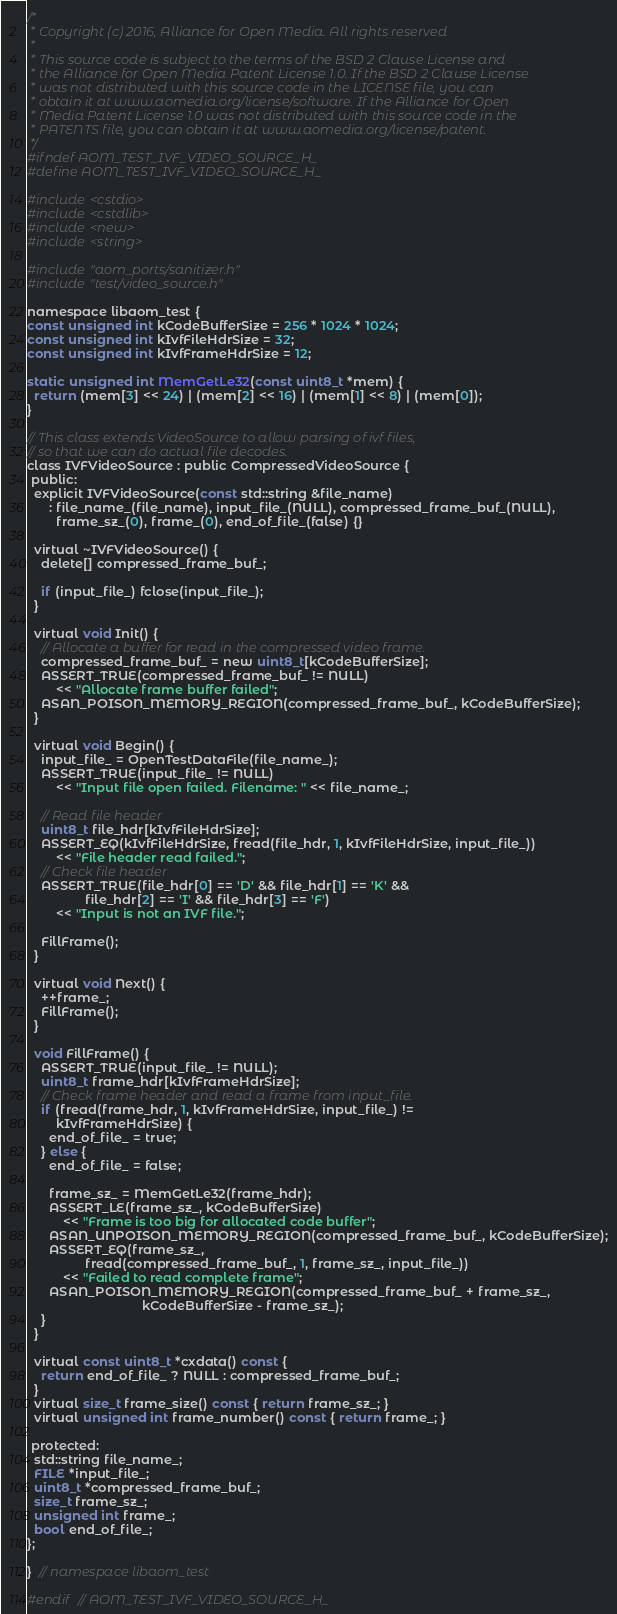Convert code to text. <code><loc_0><loc_0><loc_500><loc_500><_C_>/*
 * Copyright (c) 2016, Alliance for Open Media. All rights reserved
 *
 * This source code is subject to the terms of the BSD 2 Clause License and
 * the Alliance for Open Media Patent License 1.0. If the BSD 2 Clause License
 * was not distributed with this source code in the LICENSE file, you can
 * obtain it at www.aomedia.org/license/software. If the Alliance for Open
 * Media Patent License 1.0 was not distributed with this source code in the
 * PATENTS file, you can obtain it at www.aomedia.org/license/patent.
 */
#ifndef AOM_TEST_IVF_VIDEO_SOURCE_H_
#define AOM_TEST_IVF_VIDEO_SOURCE_H_

#include <cstdio>
#include <cstdlib>
#include <new>
#include <string>

#include "aom_ports/sanitizer.h"
#include "test/video_source.h"

namespace libaom_test {
const unsigned int kCodeBufferSize = 256 * 1024 * 1024;
const unsigned int kIvfFileHdrSize = 32;
const unsigned int kIvfFrameHdrSize = 12;

static unsigned int MemGetLe32(const uint8_t *mem) {
  return (mem[3] << 24) | (mem[2] << 16) | (mem[1] << 8) | (mem[0]);
}

// This class extends VideoSource to allow parsing of ivf files,
// so that we can do actual file decodes.
class IVFVideoSource : public CompressedVideoSource {
 public:
  explicit IVFVideoSource(const std::string &file_name)
      : file_name_(file_name), input_file_(NULL), compressed_frame_buf_(NULL),
        frame_sz_(0), frame_(0), end_of_file_(false) {}

  virtual ~IVFVideoSource() {
    delete[] compressed_frame_buf_;

    if (input_file_) fclose(input_file_);
  }

  virtual void Init() {
    // Allocate a buffer for read in the compressed video frame.
    compressed_frame_buf_ = new uint8_t[kCodeBufferSize];
    ASSERT_TRUE(compressed_frame_buf_ != NULL)
        << "Allocate frame buffer failed";
    ASAN_POISON_MEMORY_REGION(compressed_frame_buf_, kCodeBufferSize);
  }

  virtual void Begin() {
    input_file_ = OpenTestDataFile(file_name_);
    ASSERT_TRUE(input_file_ != NULL)
        << "Input file open failed. Filename: " << file_name_;

    // Read file header
    uint8_t file_hdr[kIvfFileHdrSize];
    ASSERT_EQ(kIvfFileHdrSize, fread(file_hdr, 1, kIvfFileHdrSize, input_file_))
        << "File header read failed.";
    // Check file header
    ASSERT_TRUE(file_hdr[0] == 'D' && file_hdr[1] == 'K' &&
                file_hdr[2] == 'I' && file_hdr[3] == 'F')
        << "Input is not an IVF file.";

    FillFrame();
  }

  virtual void Next() {
    ++frame_;
    FillFrame();
  }

  void FillFrame() {
    ASSERT_TRUE(input_file_ != NULL);
    uint8_t frame_hdr[kIvfFrameHdrSize];
    // Check frame header and read a frame from input_file.
    if (fread(frame_hdr, 1, kIvfFrameHdrSize, input_file_) !=
        kIvfFrameHdrSize) {
      end_of_file_ = true;
    } else {
      end_of_file_ = false;

      frame_sz_ = MemGetLe32(frame_hdr);
      ASSERT_LE(frame_sz_, kCodeBufferSize)
          << "Frame is too big for allocated code buffer";
      ASAN_UNPOISON_MEMORY_REGION(compressed_frame_buf_, kCodeBufferSize);
      ASSERT_EQ(frame_sz_,
                fread(compressed_frame_buf_, 1, frame_sz_, input_file_))
          << "Failed to read complete frame";
      ASAN_POISON_MEMORY_REGION(compressed_frame_buf_ + frame_sz_,
                                kCodeBufferSize - frame_sz_);
    }
  }

  virtual const uint8_t *cxdata() const {
    return end_of_file_ ? NULL : compressed_frame_buf_;
  }
  virtual size_t frame_size() const { return frame_sz_; }
  virtual unsigned int frame_number() const { return frame_; }

 protected:
  std::string file_name_;
  FILE *input_file_;
  uint8_t *compressed_frame_buf_;
  size_t frame_sz_;
  unsigned int frame_;
  bool end_of_file_;
};

}  // namespace libaom_test

#endif  // AOM_TEST_IVF_VIDEO_SOURCE_H_
</code> 